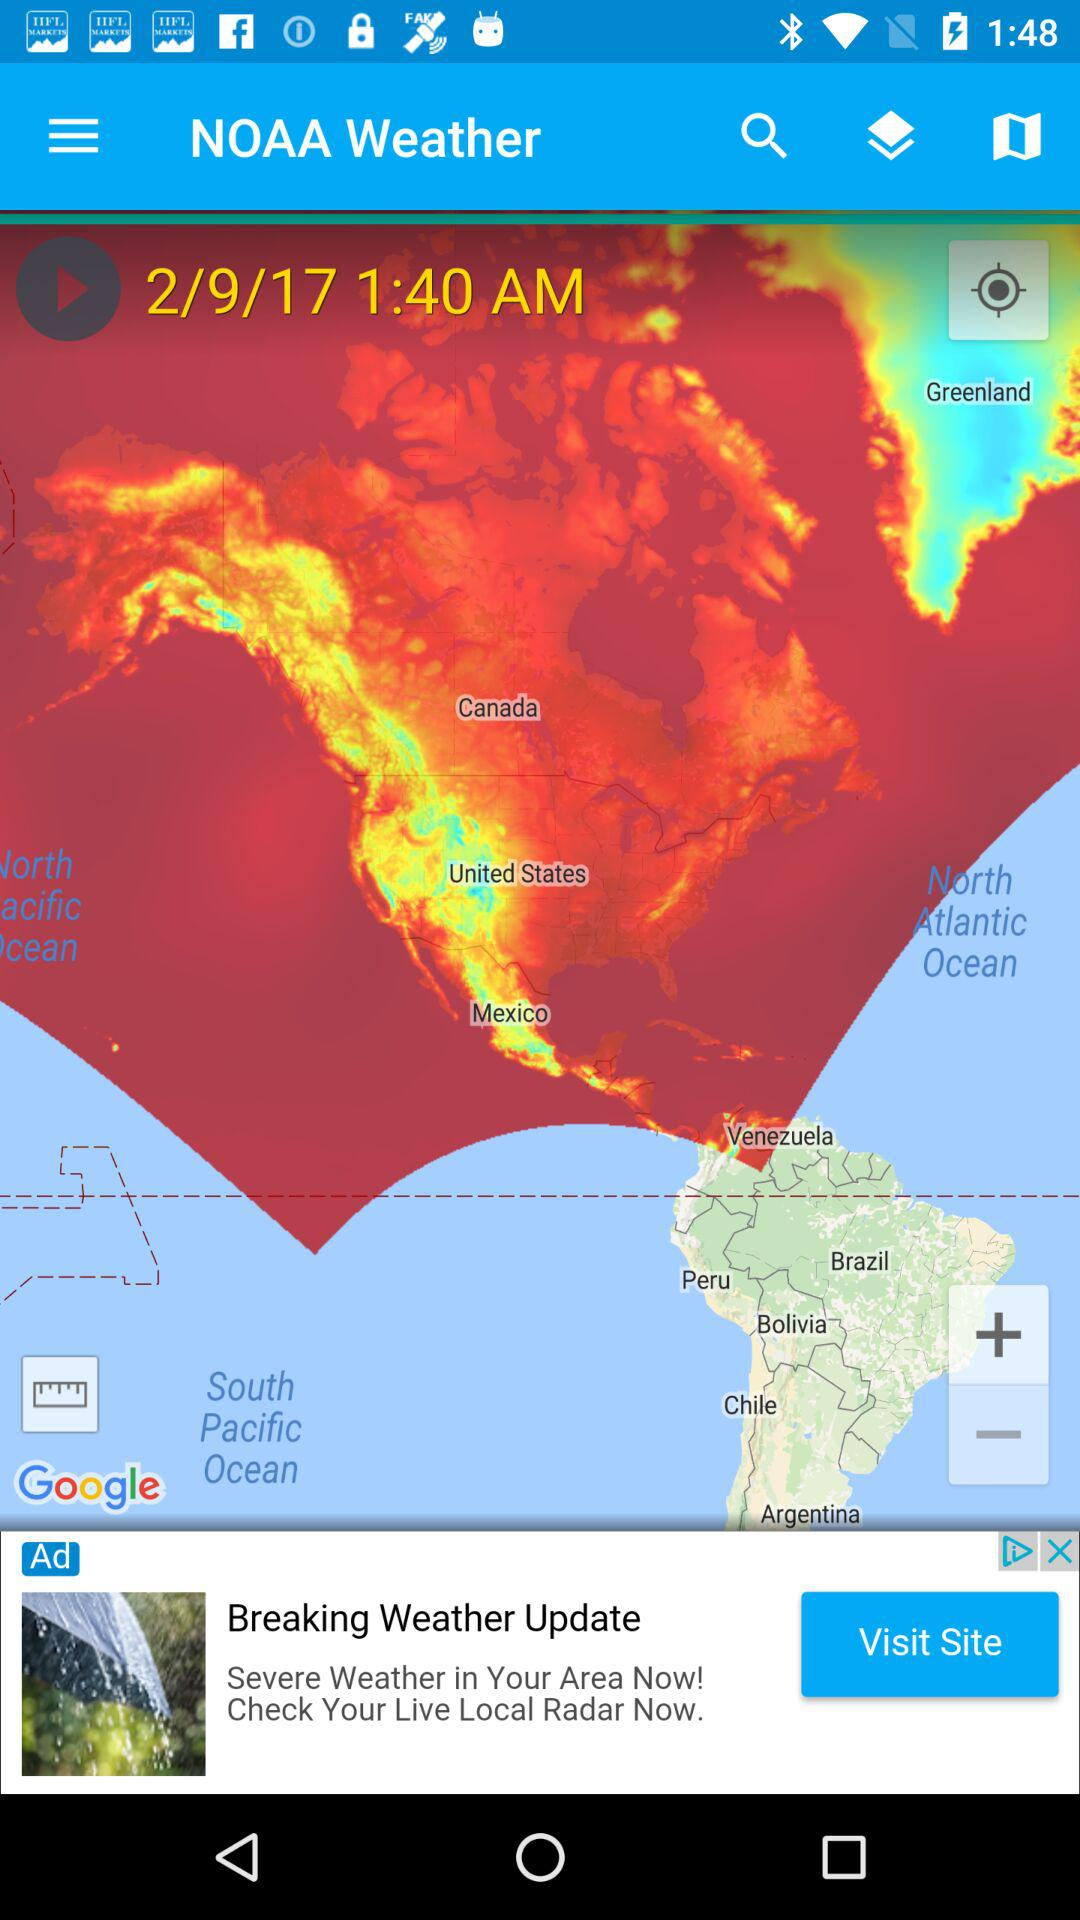What is the application name? The application name is "NOAA Weather". 